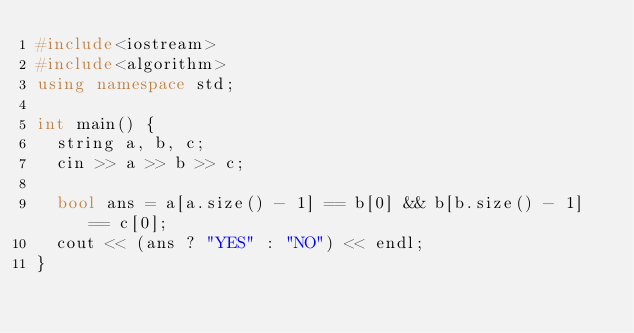Convert code to text. <code><loc_0><loc_0><loc_500><loc_500><_C++_>#include<iostream>
#include<algorithm>
using namespace std;

int main() {
  string a, b, c;
  cin >> a >> b >> c;

  bool ans = a[a.size() - 1] == b[0] && b[b.size() - 1] == c[0];
  cout << (ans ? "YES" : "NO") << endl;
}
</code> 